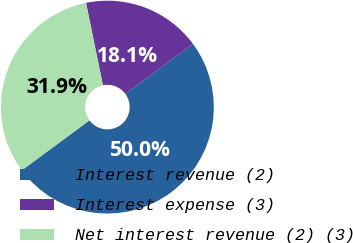Convert chart. <chart><loc_0><loc_0><loc_500><loc_500><pie_chart><fcel>Interest revenue (2)<fcel>Interest expense (3)<fcel>Net interest revenue (2) (3)<nl><fcel>50.0%<fcel>18.09%<fcel>31.91%<nl></chart> 